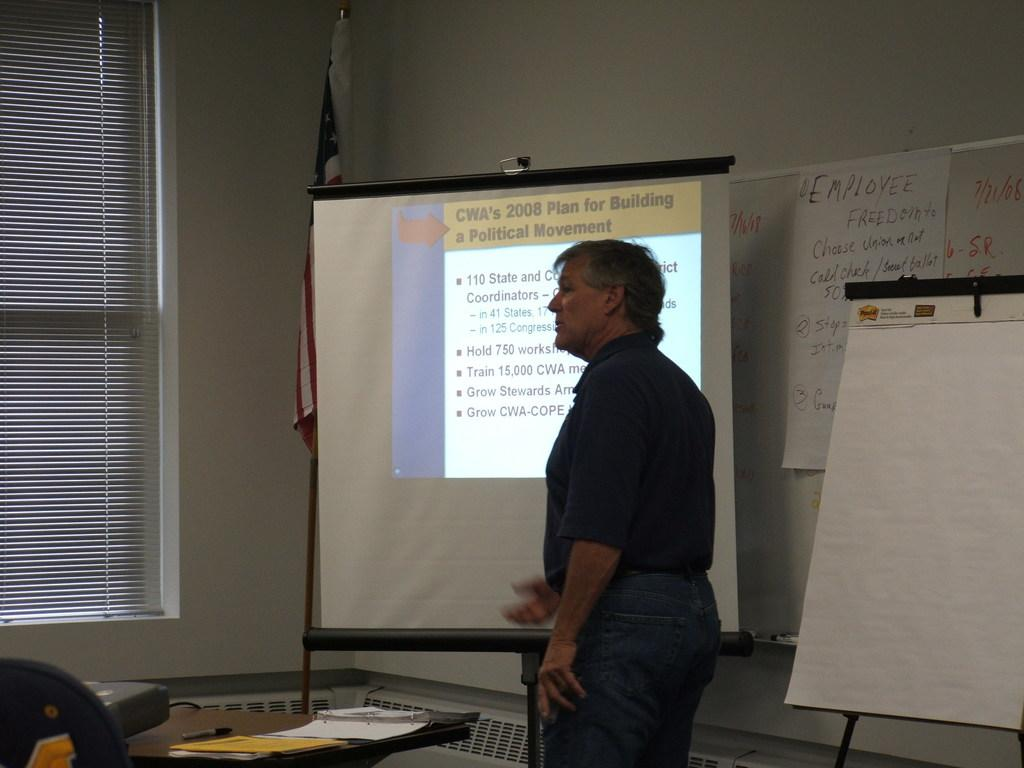<image>
Provide a brief description of the given image. a man is discussing CNA 2008 Plan to people. 